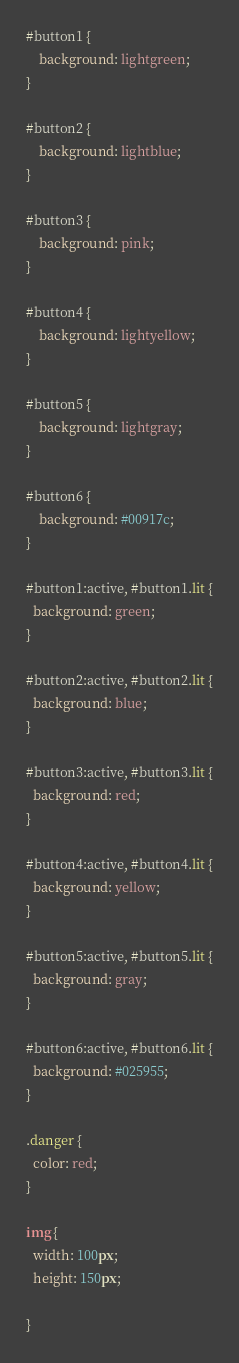Convert code to text. <code><loc_0><loc_0><loc_500><loc_500><_CSS_>
#button1 {
    background: lightgreen;
}

#button2 {
    background: lightblue;
}

#button3 {
    background: pink;
}

#button4 {
    background: lightyellow;
}

#button5 {
    background: lightgray;
}

#button6 {
    background: #00917c;
}

#button1:active, #button1.lit {
  background: green;
}

#button2:active, #button2.lit {
  background: blue;
}

#button3:active, #button3.lit {
  background: red;
}

#button4:active, #button4.lit {
  background: yellow;
}

#button5:active, #button5.lit {
  background: gray;
}

#button6:active, #button6.lit {
  background: #025955;
}

.danger {
  color: red;
}

img {
  width: 100px;
  height: 150px;

}


</code> 